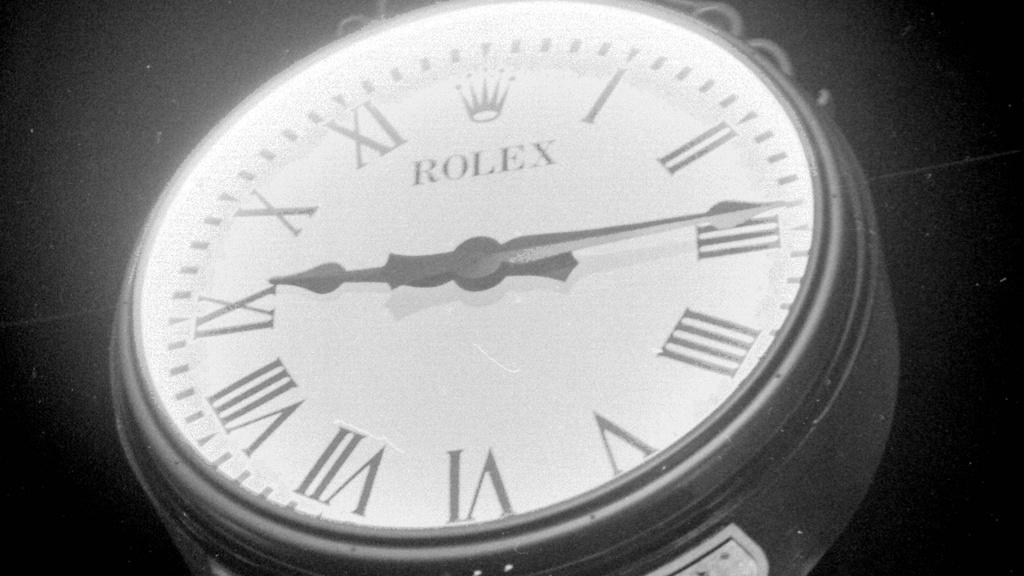<image>
Give a short and clear explanation of the subsequent image. A closeup on a Rolex watch with a white face against a black backdrop. 